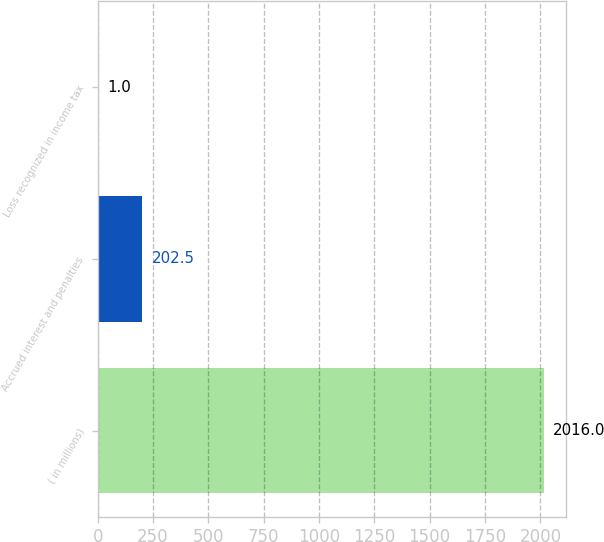Convert chart. <chart><loc_0><loc_0><loc_500><loc_500><bar_chart><fcel>( in millions)<fcel>Accrued interest and penalties<fcel>Loss recognized in income tax<nl><fcel>2016<fcel>202.5<fcel>1<nl></chart> 